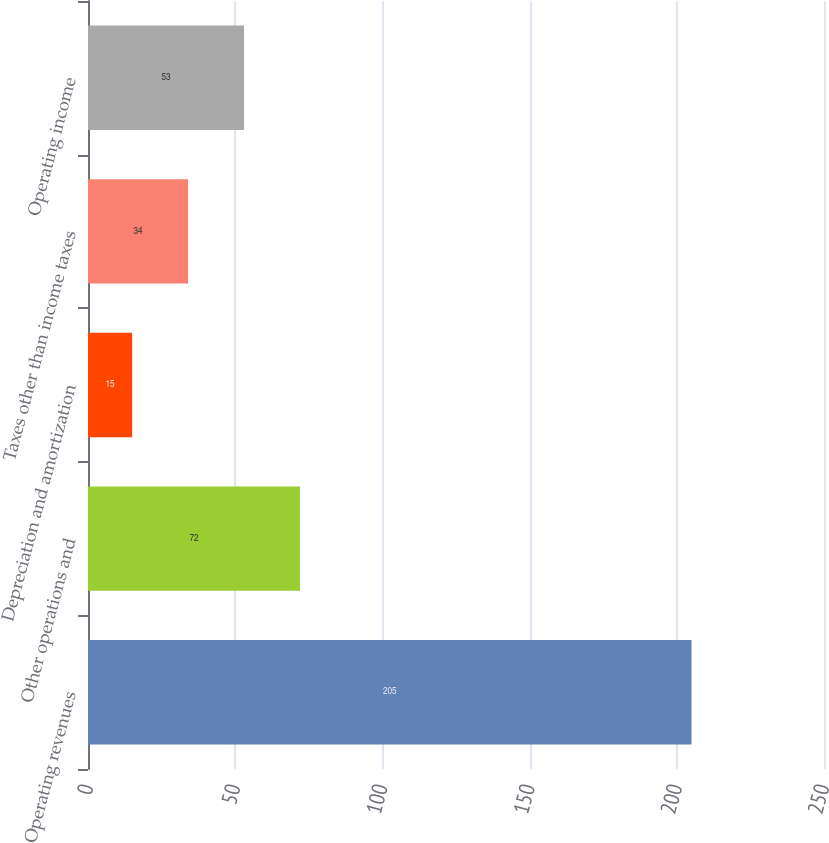<chart> <loc_0><loc_0><loc_500><loc_500><bar_chart><fcel>Operating revenues<fcel>Other operations and<fcel>Depreciation and amortization<fcel>Taxes other than income taxes<fcel>Operating income<nl><fcel>205<fcel>72<fcel>15<fcel>34<fcel>53<nl></chart> 